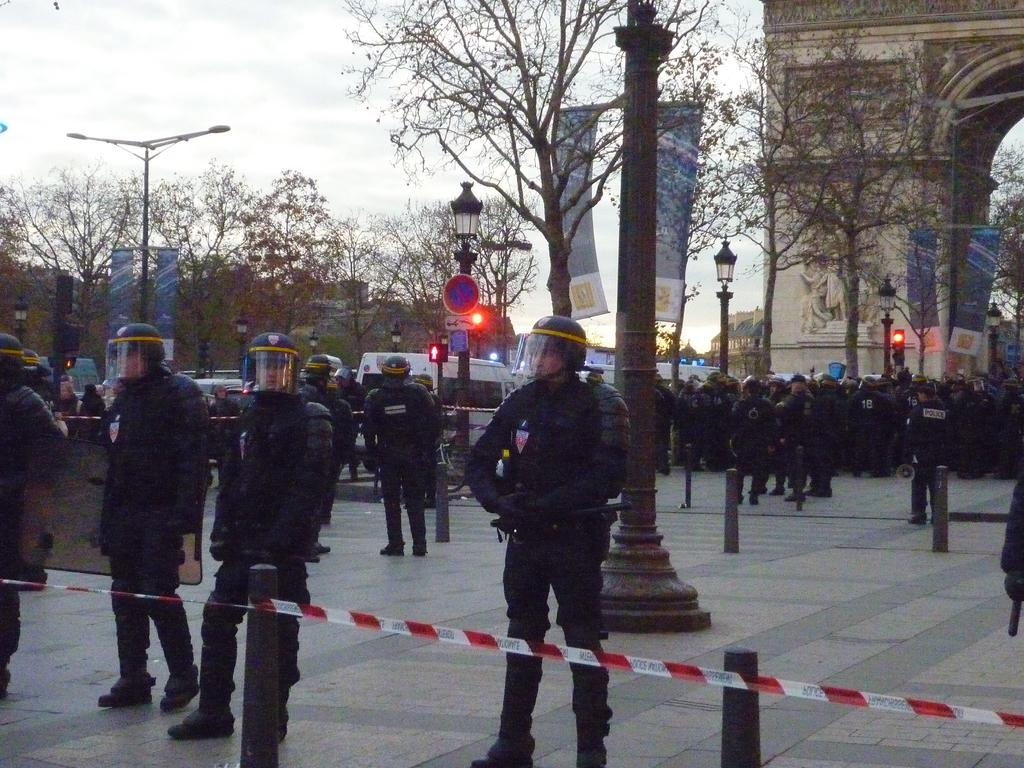How many people are in the image? There is a group of people in the image. What objects can be seen in the image that are related to infrastructure? There are poles, boards, traffic signals, and banners in the image. What types of vehicles are present in the image? There are vehicles in the image. What natural elements can be seen in the image? There are trees in the image. What man-made structures are visible in the image? There are buildings in the image. What is visible in the background of the image? The sky is visible in the background of the image. How much money is being exchanged between the people in the image? There is no indication of money being exchanged in the image. What type of nail is being used to hang the banners in the image? There is no nail visible in the image; the banners are attached to poles or other structures. Can you see any beetles crawling on the trees in the image? There is no mention of beetles or any other insects in the image. 